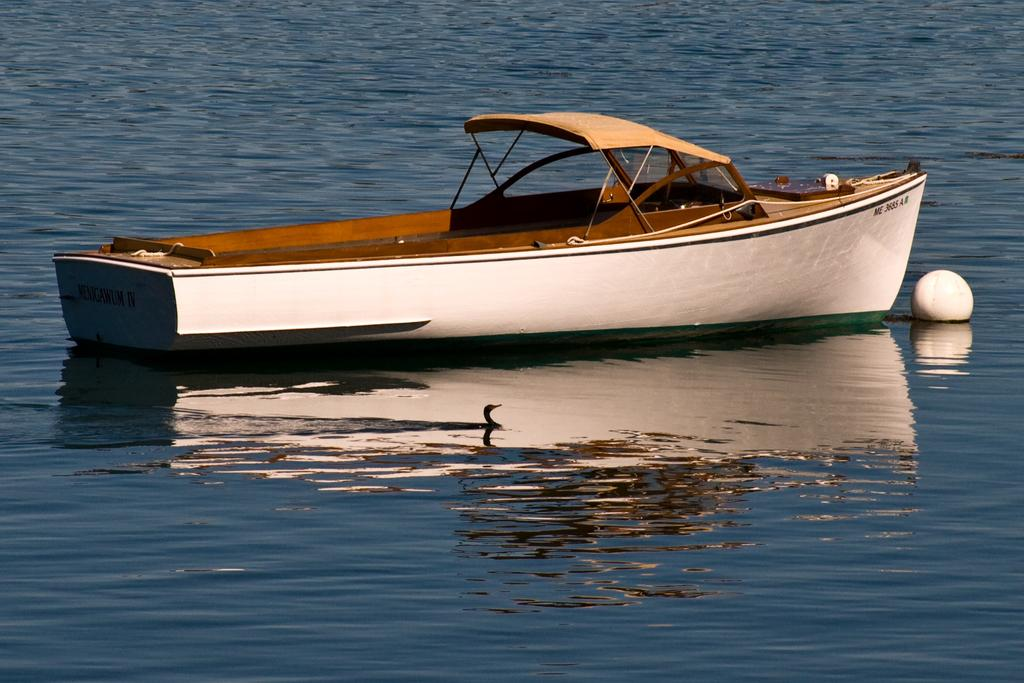What is the main subject in the image? There is a boat in the image. What other object can be seen in the image? There is a white color object in the image. Where are both the boat and the white color object located? Both the boat and the white color object are on the water. What type of fowl can be seen walking along the line in the image? There is no fowl or line present in the image. What is the thing that the boat is pulling in the image? There is no boat pulling any object in the image; the boat and the white color object are both on the water. 